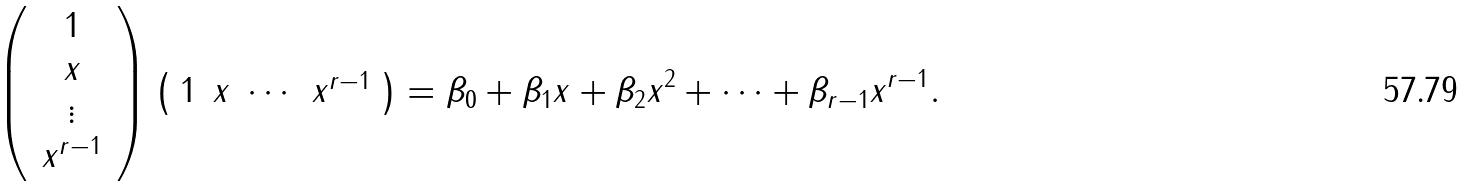<formula> <loc_0><loc_0><loc_500><loc_500>\left ( \, \begin{array} { c } 1 \\ x \\ \vdots \\ x ^ { r - 1 } \end{array} \, \right ) \left ( \begin{array} { c c c c } 1 & x & \cdots & x ^ { r - 1 } \end{array} \right ) = \beta _ { 0 } + \beta _ { 1 } x + \beta _ { 2 } x ^ { 2 } + \cdots + \beta _ { r - 1 } x ^ { r - 1 } .</formula> 